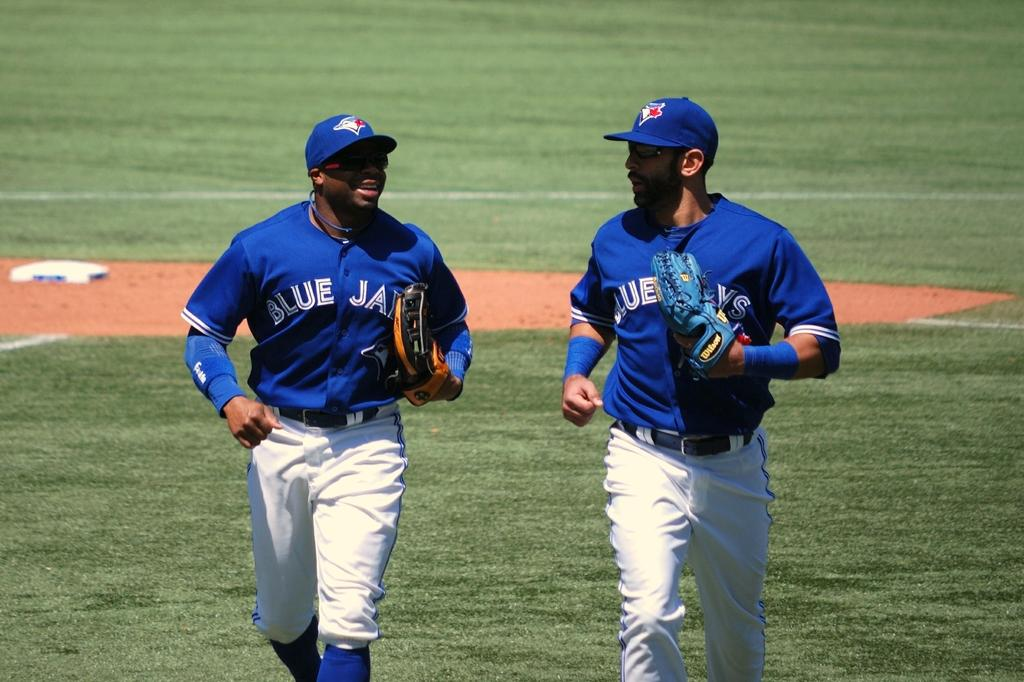<image>
Write a terse but informative summary of the picture. Two Blue Jays players walking on the field. 